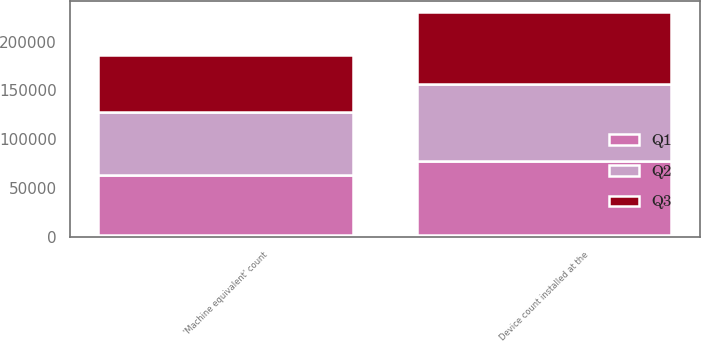<chart> <loc_0><loc_0><loc_500><loc_500><stacked_bar_chart><ecel><fcel>Device count installed at the<fcel>'Machine equivalent' count<nl><fcel>nan<fcel>2018<fcel>2018<nl><fcel>Q3<fcel>73561<fcel>58571<nl><fcel>Q1<fcel>76069<fcel>61405<nl><fcel>Q2<fcel>78706<fcel>64205<nl></chart> 